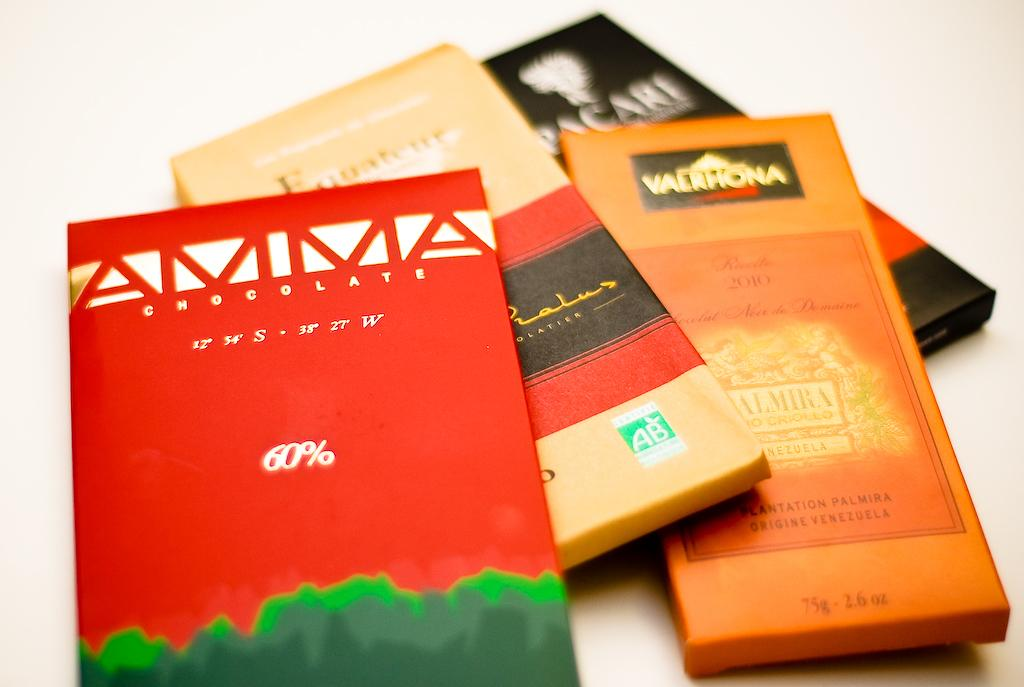Provide a one-sentence caption for the provided image. Four bars of chocolate are shown and one is an Amma brand. 